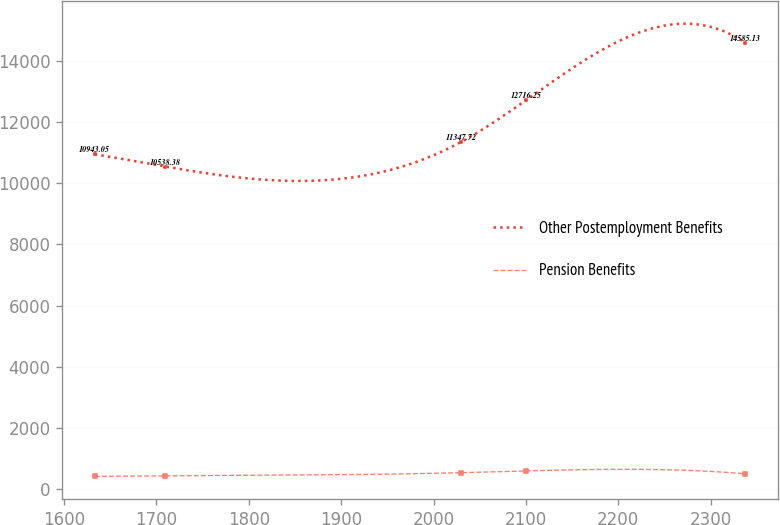Convert chart. <chart><loc_0><loc_0><loc_500><loc_500><line_chart><ecel><fcel>Other Postemployment Benefits<fcel>Pension Benefits<nl><fcel>1633.22<fcel>10943<fcel>418.12<nl><fcel>1709.73<fcel>10538.4<fcel>436.06<nl><fcel>2030.03<fcel>11347.7<fcel>539.69<nl><fcel>2100.47<fcel>12716.2<fcel>597.55<nl><fcel>2337.65<fcel>14585.1<fcel>503.05<nl></chart> 